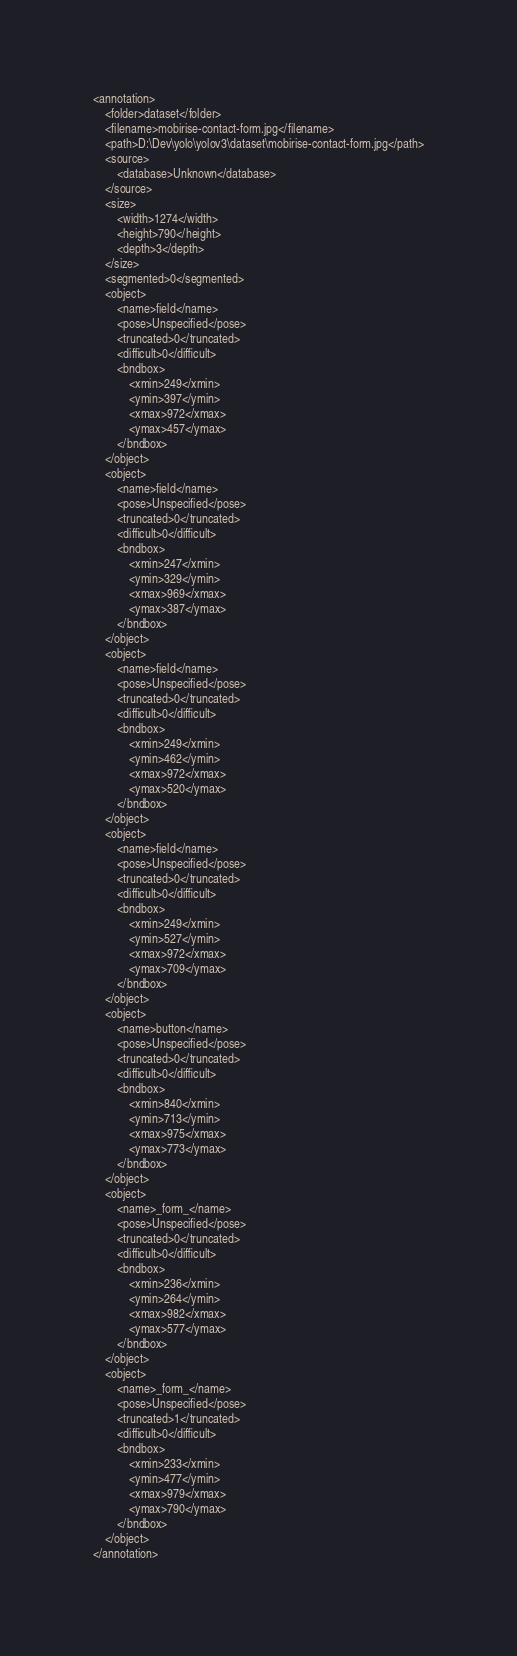Convert code to text. <code><loc_0><loc_0><loc_500><loc_500><_XML_><annotation>
	<folder>dataset</folder>
	<filename>mobirise-contact-form.jpg</filename>
	<path>D:\Dev\yolo\yolov3\dataset\mobirise-contact-form.jpg</path>
	<source>
		<database>Unknown</database>
	</source>
	<size>
		<width>1274</width>
		<height>790</height>
		<depth>3</depth>
	</size>
	<segmented>0</segmented>
	<object>
		<name>field</name>
		<pose>Unspecified</pose>
		<truncated>0</truncated>
		<difficult>0</difficult>
		<bndbox>
			<xmin>249</xmin>
			<ymin>397</ymin>
			<xmax>972</xmax>
			<ymax>457</ymax>
		</bndbox>
	</object>
	<object>
		<name>field</name>
		<pose>Unspecified</pose>
		<truncated>0</truncated>
		<difficult>0</difficult>
		<bndbox>
			<xmin>247</xmin>
			<ymin>329</ymin>
			<xmax>969</xmax>
			<ymax>387</ymax>
		</bndbox>
	</object>
	<object>
		<name>field</name>
		<pose>Unspecified</pose>
		<truncated>0</truncated>
		<difficult>0</difficult>
		<bndbox>
			<xmin>249</xmin>
			<ymin>462</ymin>
			<xmax>972</xmax>
			<ymax>520</ymax>
		</bndbox>
	</object>
	<object>
		<name>field</name>
		<pose>Unspecified</pose>
		<truncated>0</truncated>
		<difficult>0</difficult>
		<bndbox>
			<xmin>249</xmin>
			<ymin>527</ymin>
			<xmax>972</xmax>
			<ymax>709</ymax>
		</bndbox>
	</object>
	<object>
		<name>button</name>
		<pose>Unspecified</pose>
		<truncated>0</truncated>
		<difficult>0</difficult>
		<bndbox>
			<xmin>840</xmin>
			<ymin>713</ymin>
			<xmax>975</xmax>
			<ymax>773</ymax>
		</bndbox>
	</object>
	<object>
		<name>_form_</name>
		<pose>Unspecified</pose>
		<truncated>0</truncated>
		<difficult>0</difficult>
		<bndbox>
			<xmin>236</xmin>
			<ymin>264</ymin>
			<xmax>982</xmax>
			<ymax>577</ymax>
		</bndbox>
	</object>
	<object>
		<name>_form_</name>
		<pose>Unspecified</pose>
		<truncated>1</truncated>
		<difficult>0</difficult>
		<bndbox>
			<xmin>233</xmin>
			<ymin>477</ymin>
			<xmax>979</xmax>
			<ymax>790</ymax>
		</bndbox>
	</object>
</annotation>
</code> 